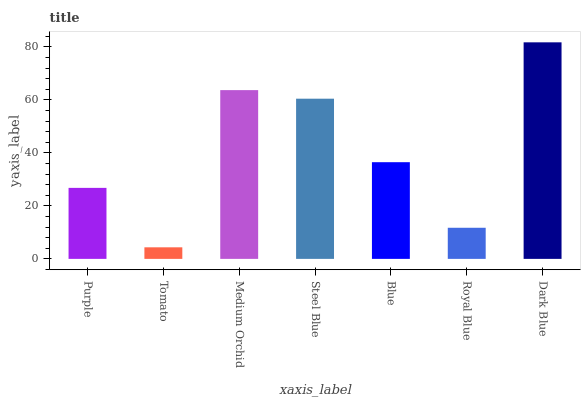Is Tomato the minimum?
Answer yes or no. Yes. Is Dark Blue the maximum?
Answer yes or no. Yes. Is Medium Orchid the minimum?
Answer yes or no. No. Is Medium Orchid the maximum?
Answer yes or no. No. Is Medium Orchid greater than Tomato?
Answer yes or no. Yes. Is Tomato less than Medium Orchid?
Answer yes or no. Yes. Is Tomato greater than Medium Orchid?
Answer yes or no. No. Is Medium Orchid less than Tomato?
Answer yes or no. No. Is Blue the high median?
Answer yes or no. Yes. Is Blue the low median?
Answer yes or no. Yes. Is Steel Blue the high median?
Answer yes or no. No. Is Purple the low median?
Answer yes or no. No. 